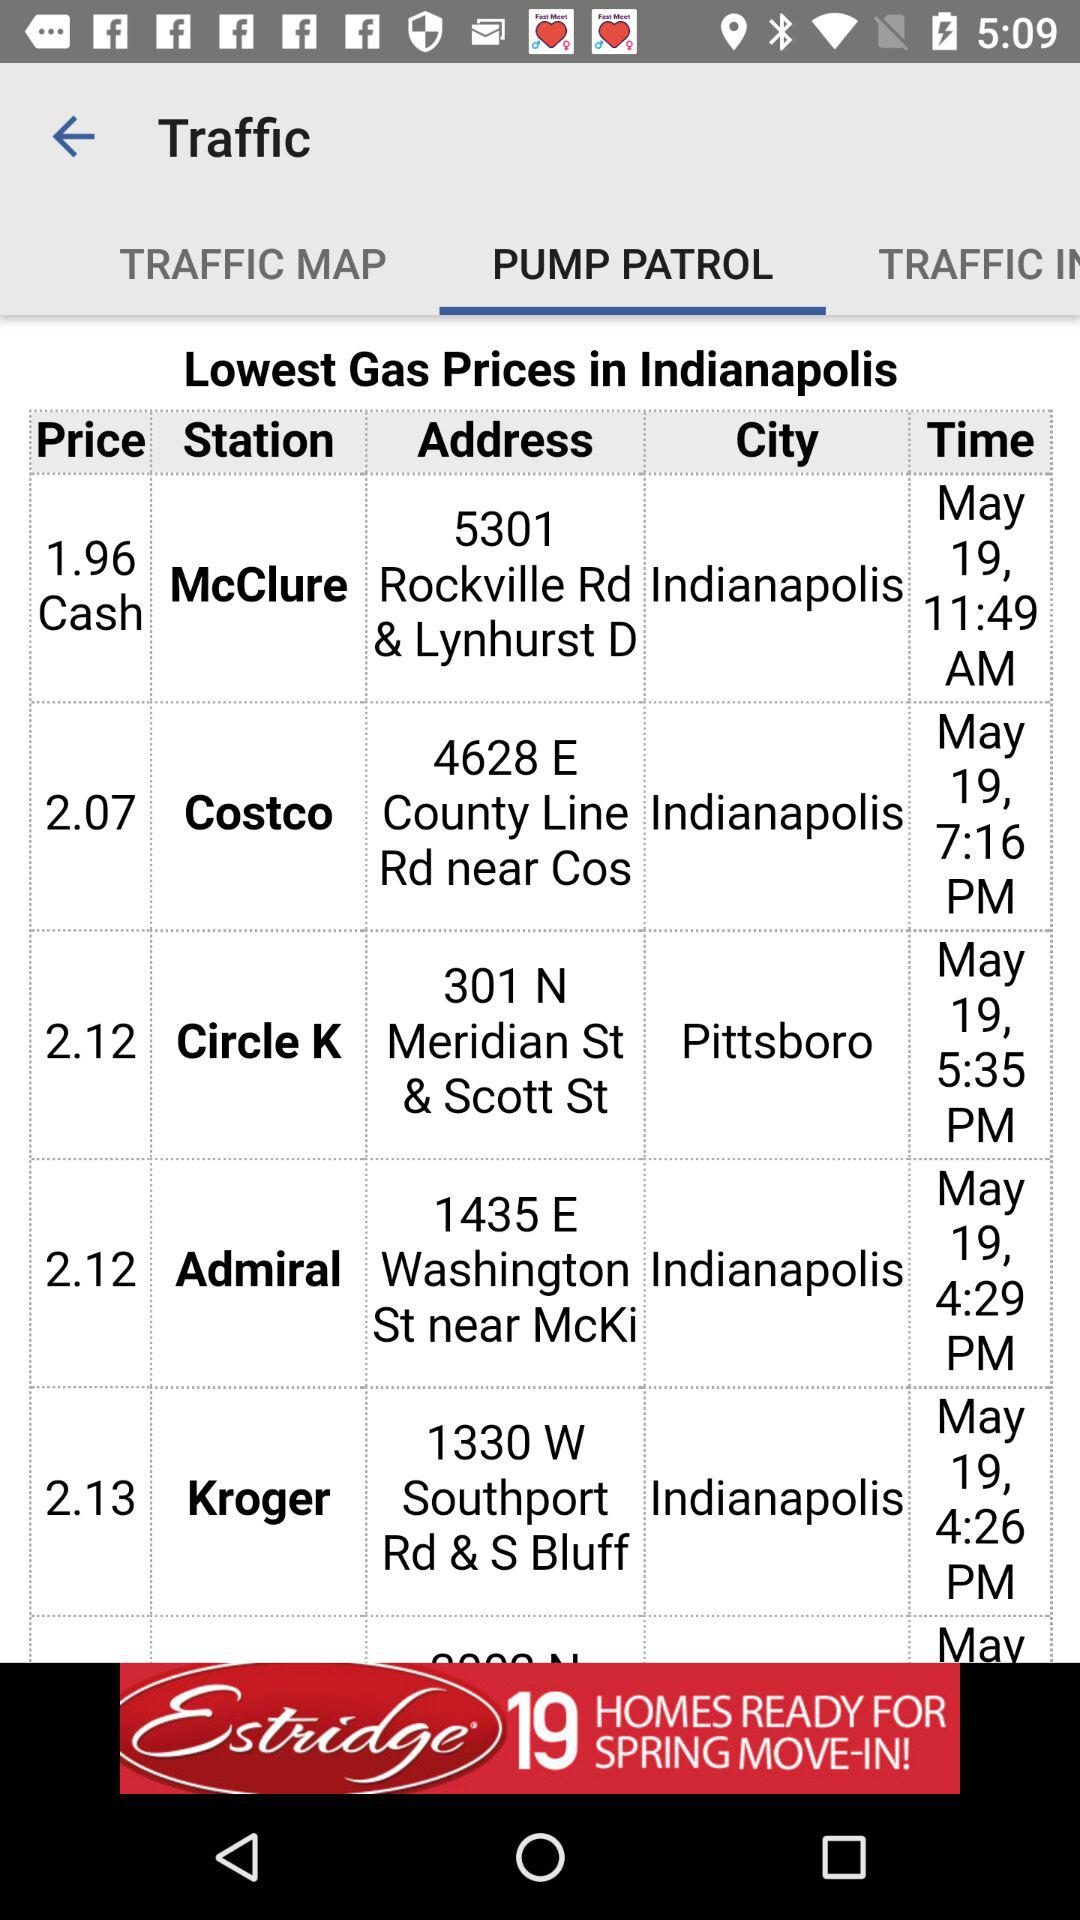What is the cash price of Admiral Station? The cash price of Admiral Station is 2.12. 